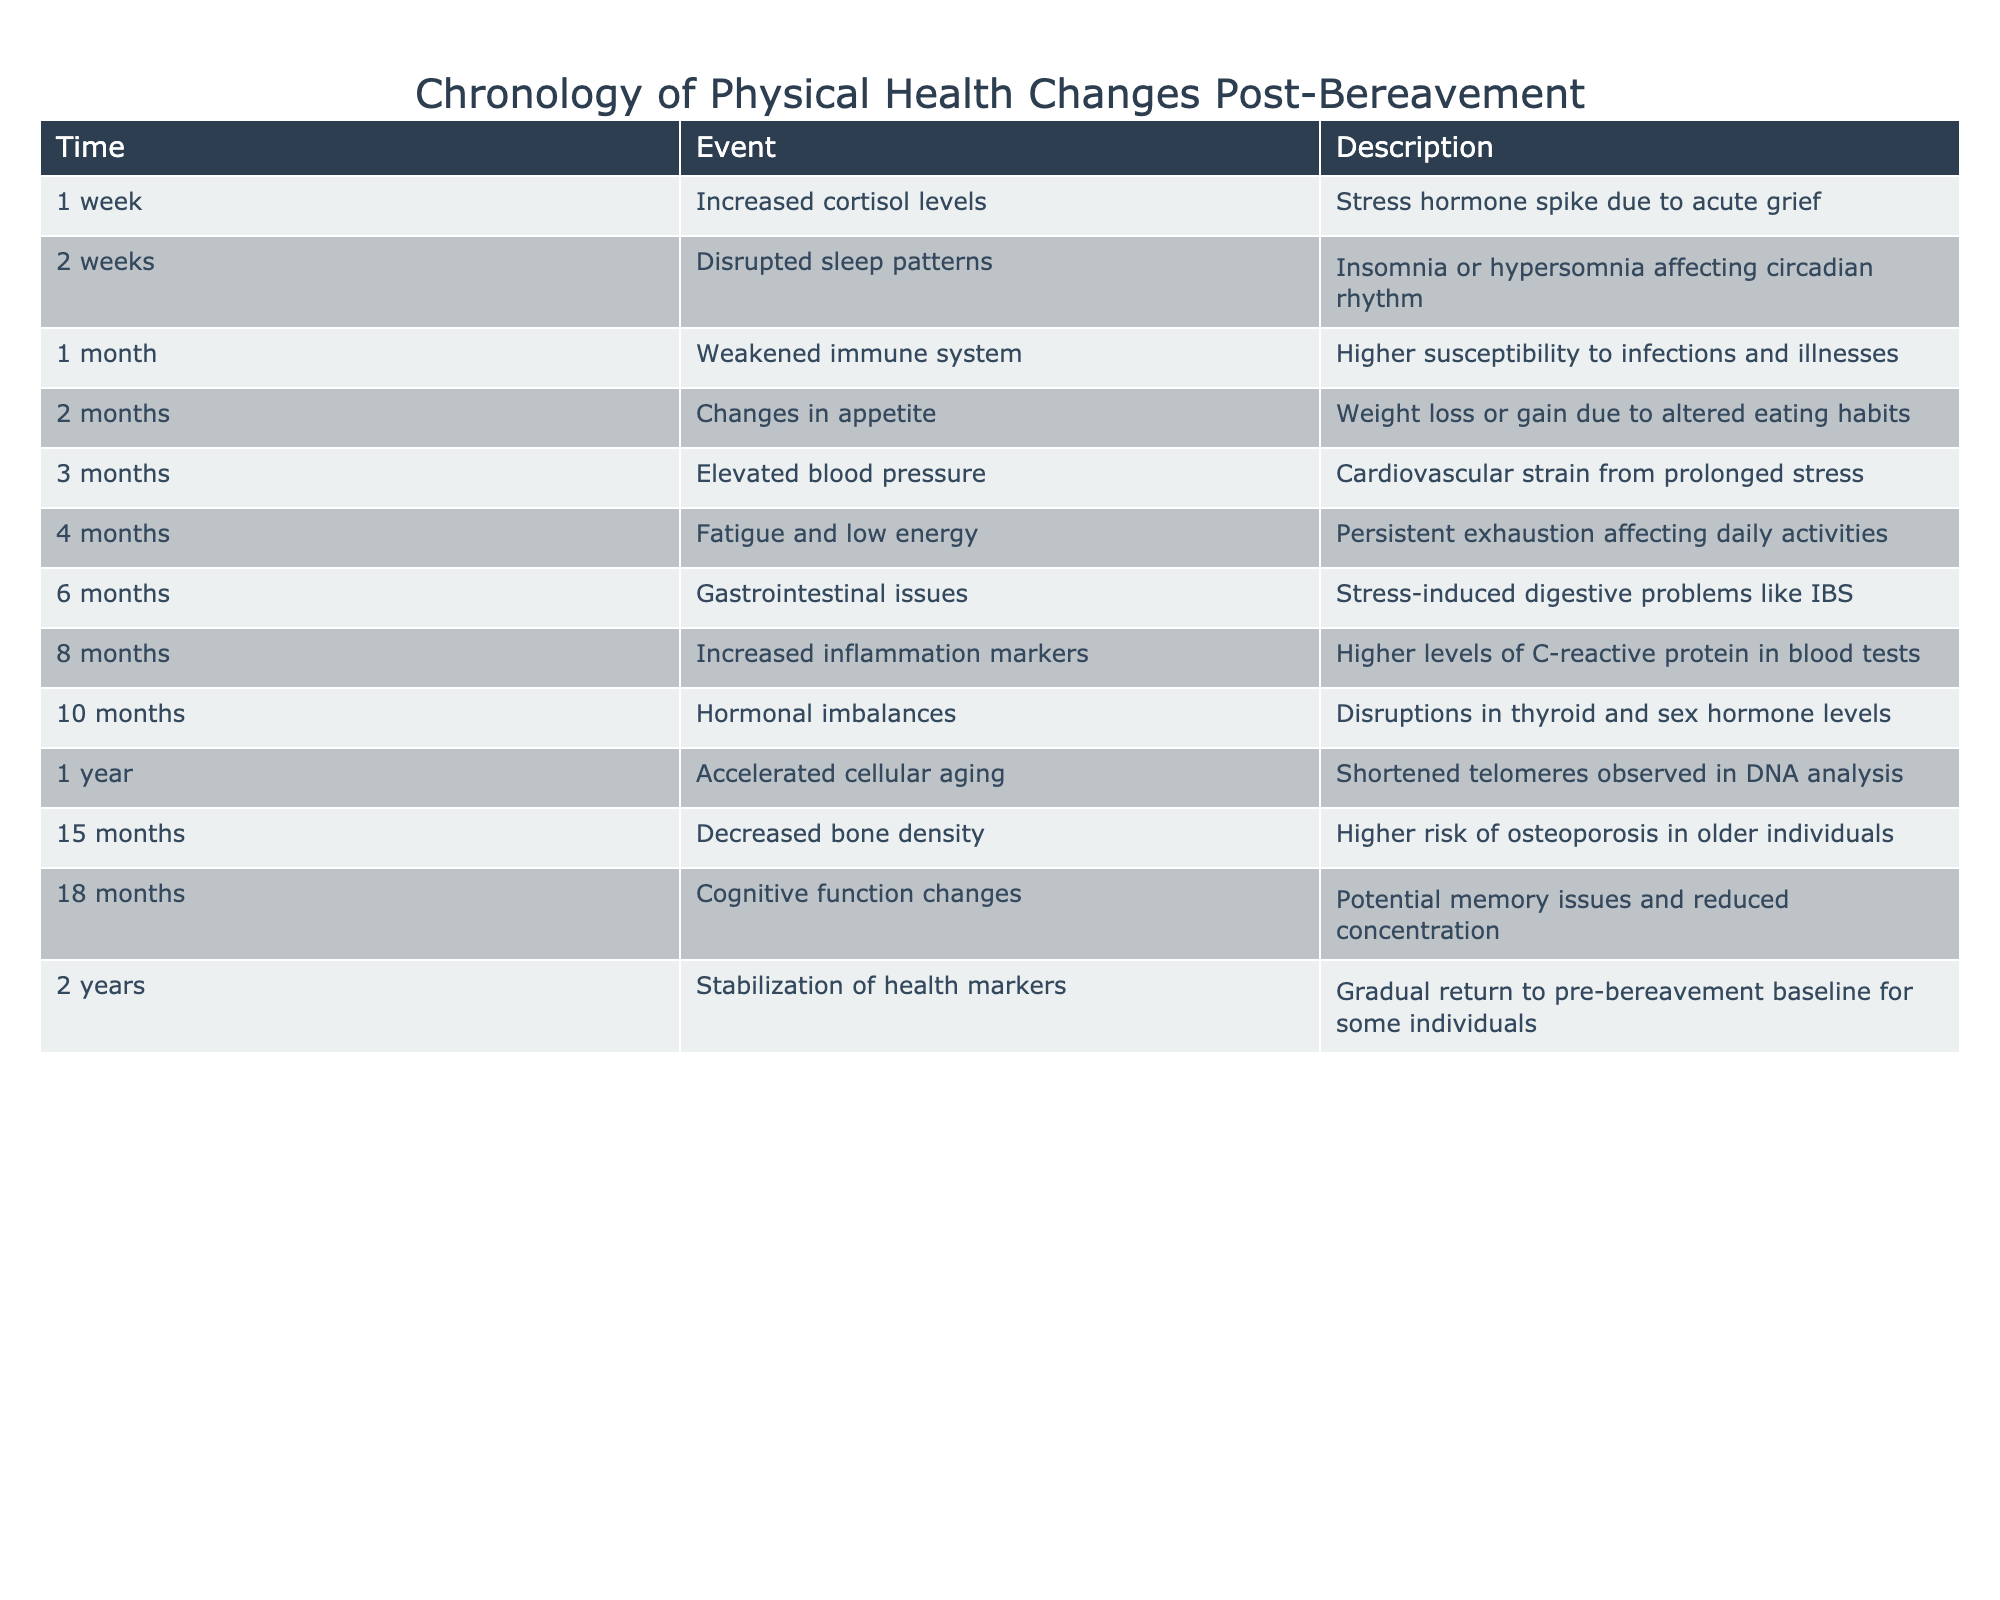What event occurs at 3 months post-bereavement? Referring to the table, at 3 months, the event noted is "Elevated blood pressure."
Answer: Elevated blood pressure How long after a loss do gastrointestinal issues begin to manifest? According to the table, gastrointestinal issues occur at 6 months post-bereavement.
Answer: 6 months Is it true that cognitive function changes occur before changes in appetite? By examining the table, cognitive function changes are listed at 18 months while changes in appetite occur at 2 months; thus, the statement is false.
Answer: No What is the difference between the time of increased cortisol levels and the time of decreased bone density? Increased cortisol levels are observed at 1 week and decreased bone density at 15 months, which is a difference of 14 months and 3 weeks.
Answer: 14 months and 3 weeks What factors could correlate with the physical health changes listed in the table over the two-year timeline? Analysis of the recorded events suggests potential correlations like stress leading to elevated blood pressure, diminished immune response, and fatigue that could contribute to long-term issues like cognitive changes or bone density reduction over time.
Answer: Stress-related health correlations How many months after bereavement do individuals start to see stabilization of health markers? From the table, stabilization of health markers occurs at 2 years or 24 months after the loss.
Answer: 24 months True or false: There is an increase in inflammation markers at 8 months post-bereavement. The table confirms that increased inflammation markers are indeed noted at 8 months, making the statement true.
Answer: Yes What is the average time in months from the increased cortisol levels to the stabilization of health markers? Increased cortisol levels are at 1 week (approximately 0.25 months) and stabilization is at 24 months. Summing this gives 24 - 0.25 = 23.75 months which rounded gives an average of approximately 23.75 months.
Answer: 23.75 months 